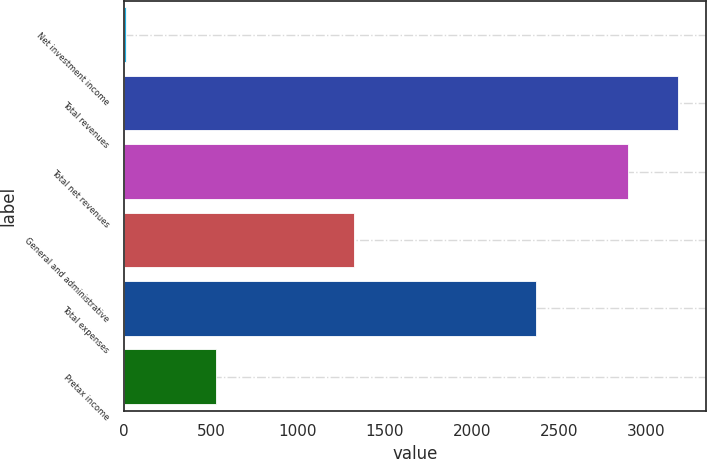Convert chart. <chart><loc_0><loc_0><loc_500><loc_500><bar_chart><fcel>Net investment income<fcel>Total revenues<fcel>Total net revenues<fcel>General and administrative<fcel>Total expenses<fcel>Pretax income<nl><fcel>11<fcel>3185.9<fcel>2897<fcel>1324<fcel>2369<fcel>528<nl></chart> 